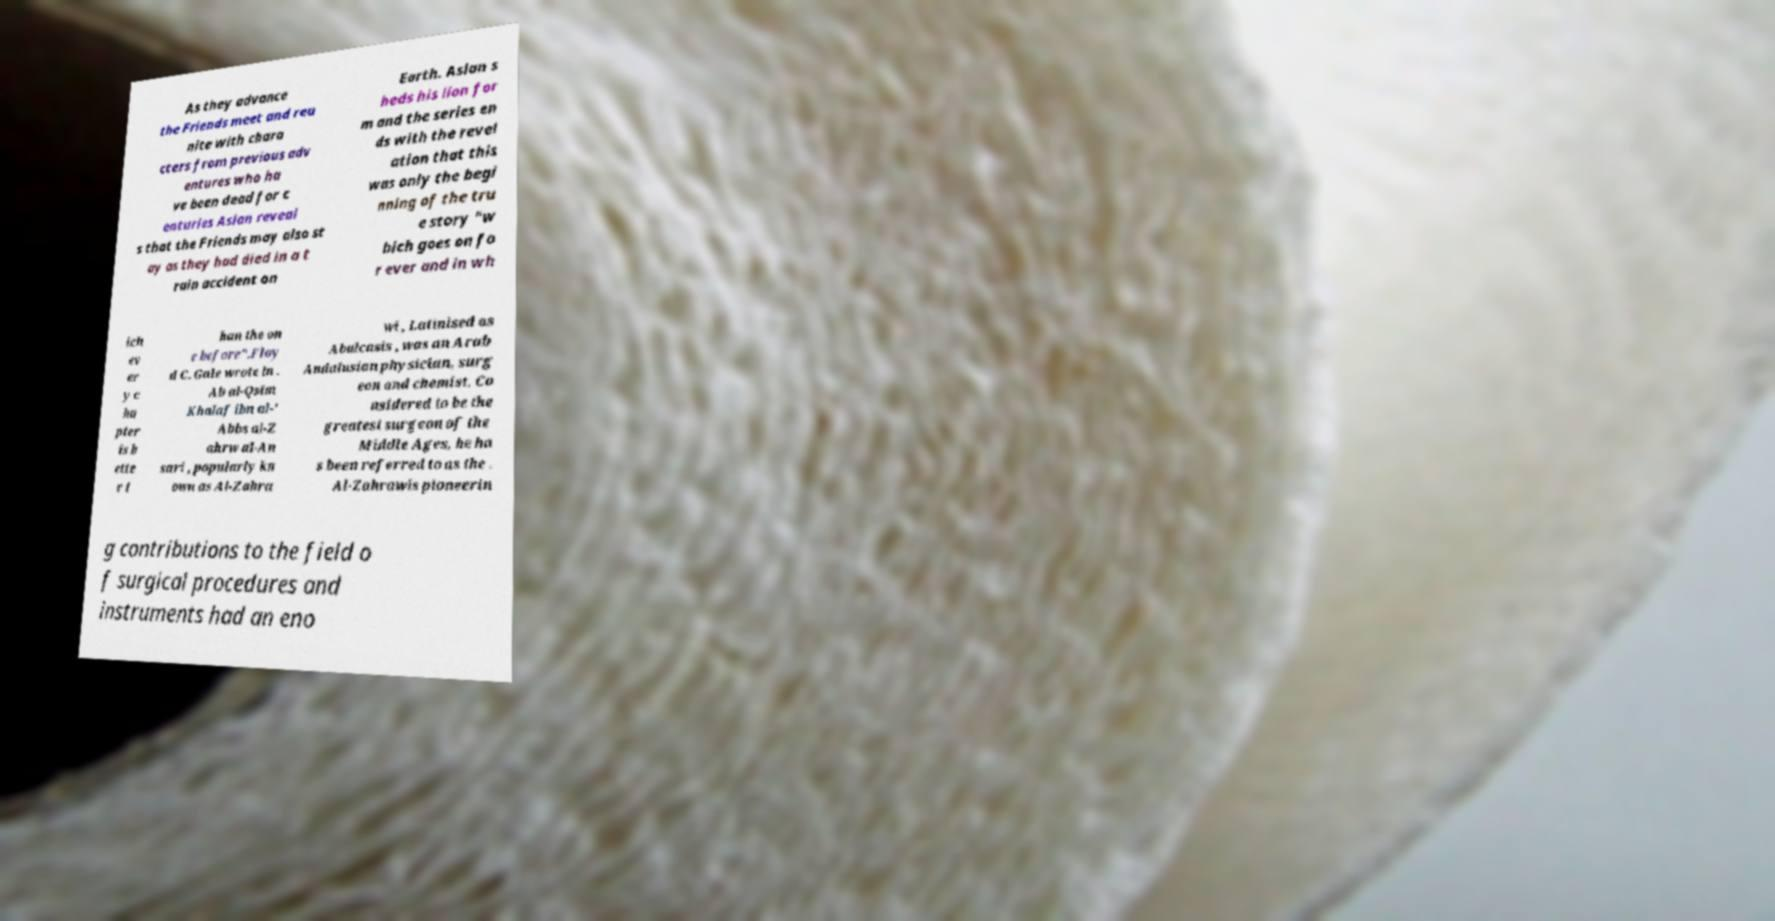For documentation purposes, I need the text within this image transcribed. Could you provide that? As they advance the Friends meet and reu nite with chara cters from previous adv entures who ha ve been dead for c enturies Aslan reveal s that the Friends may also st ay as they had died in a t rain accident on Earth. Aslan s heds his lion for m and the series en ds with the revel ation that this was only the begi nning of the tru e story "w hich goes on fo r ever and in wh ich ev er y c ha pter is b ette r t han the on e before".Floy d C. Gale wrote in . Ab al-Qsim Khalaf ibn al-' Abbs al-Z ahrw al-An sari , popularly kn own as Al-Zahra wi , Latinised as Abulcasis , was an Arab Andalusian physician, surg eon and chemist. Co nsidered to be the greatest surgeon of the Middle Ages, he ha s been referred to as the . Al-Zahrawis pioneerin g contributions to the field o f surgical procedures and instruments had an eno 